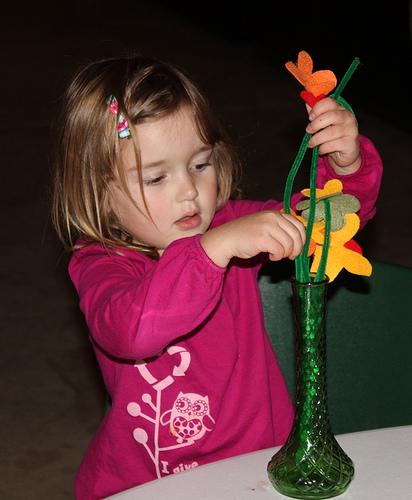Does this girl wear her natural hair color in this image?
Be succinct. Yes. Is there a clip in her hair?
Concise answer only. Yes. What is the vase made from?
Concise answer only. Glass. What color is the girls shirt?
Write a very short answer. Pink. What is the girl holding?
Give a very brief answer. Flower. How many dolls are in the image?
Quick response, please. 0. 